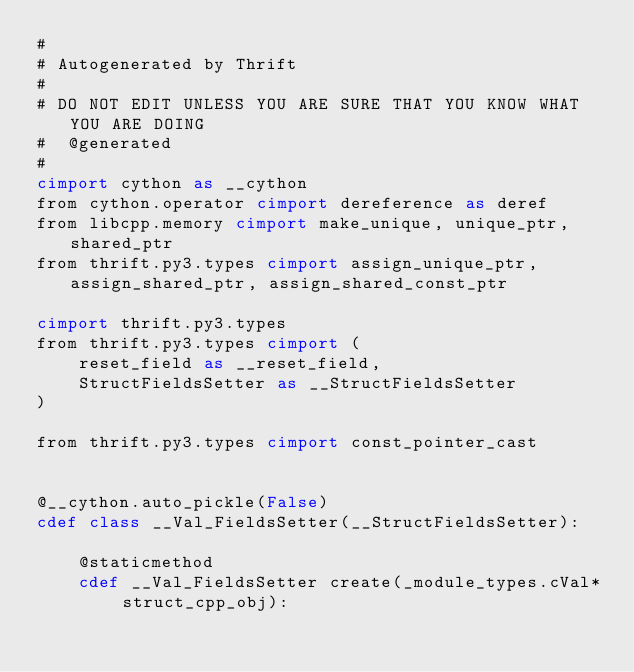<code> <loc_0><loc_0><loc_500><loc_500><_Cython_>#
# Autogenerated by Thrift
#
# DO NOT EDIT UNLESS YOU ARE SURE THAT YOU KNOW WHAT YOU ARE DOING
#  @generated
#
cimport cython as __cython
from cython.operator cimport dereference as deref
from libcpp.memory cimport make_unique, unique_ptr, shared_ptr
from thrift.py3.types cimport assign_unique_ptr, assign_shared_ptr, assign_shared_const_ptr

cimport thrift.py3.types
from thrift.py3.types cimport (
    reset_field as __reset_field,
    StructFieldsSetter as __StructFieldsSetter
)

from thrift.py3.types cimport const_pointer_cast


@__cython.auto_pickle(False)
cdef class __Val_FieldsSetter(__StructFieldsSetter):

    @staticmethod
    cdef __Val_FieldsSetter create(_module_types.cVal* struct_cpp_obj):</code> 